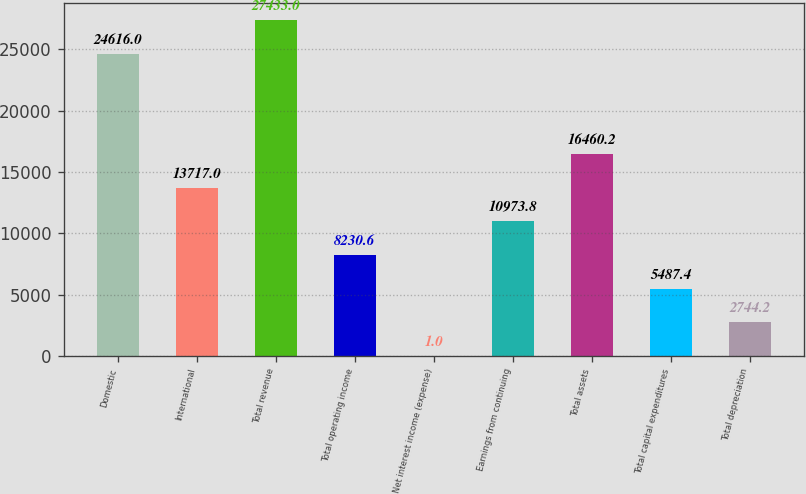Convert chart to OTSL. <chart><loc_0><loc_0><loc_500><loc_500><bar_chart><fcel>Domestic<fcel>International<fcel>Total revenue<fcel>Total operating income<fcel>Net interest income (expense)<fcel>Earnings from continuing<fcel>Total assets<fcel>Total capital expenditures<fcel>Total depreciation<nl><fcel>24616<fcel>13717<fcel>27433<fcel>8230.6<fcel>1<fcel>10973.8<fcel>16460.2<fcel>5487.4<fcel>2744.2<nl></chart> 